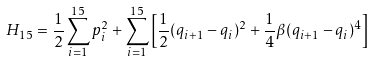<formula> <loc_0><loc_0><loc_500><loc_500>H _ { 1 5 } = \frac { 1 } { 2 } \sum _ { i = 1 } ^ { 1 5 } p _ { i } ^ { 2 } + \sum _ { i = 1 } ^ { 1 5 } \left [ \frac { 1 } { 2 } ( q _ { i + 1 } - q _ { i } ) ^ { 2 } + \frac { 1 } { 4 } \beta ( q _ { i + 1 } - q _ { i } ) ^ { 4 } \right ]</formula> 